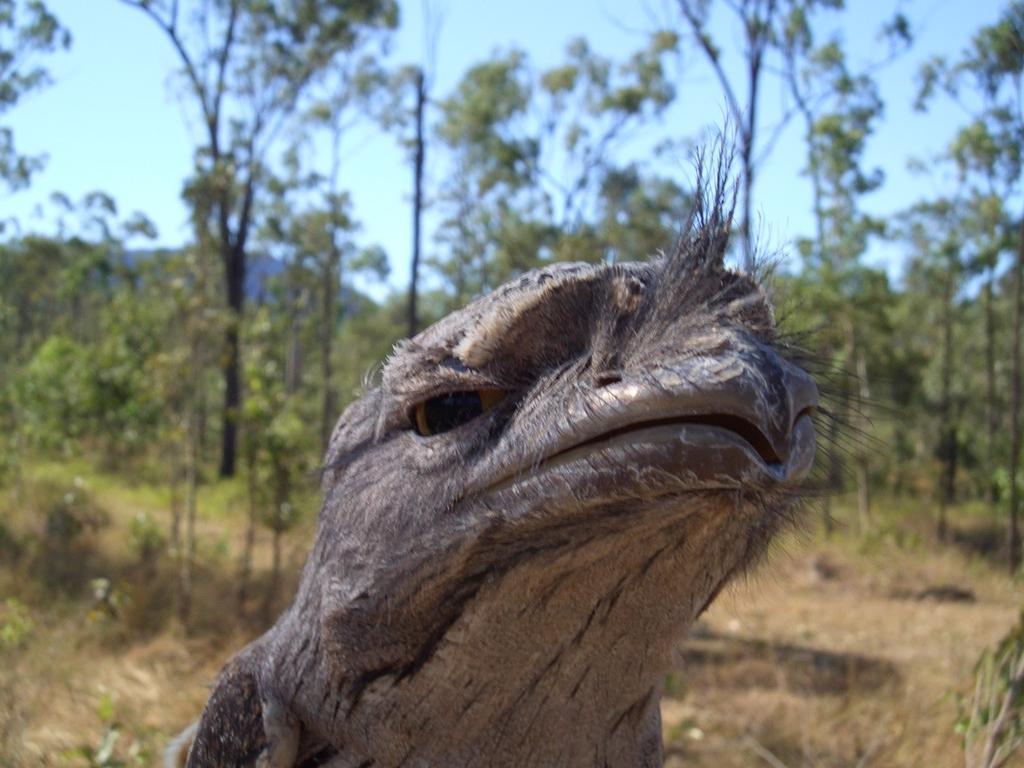Please provide a concise description of this image. In the center of the image an animal is there. In the background of the image trees, hills are there. At the top of the image sky is there. At the bottom of the image ground is there. 